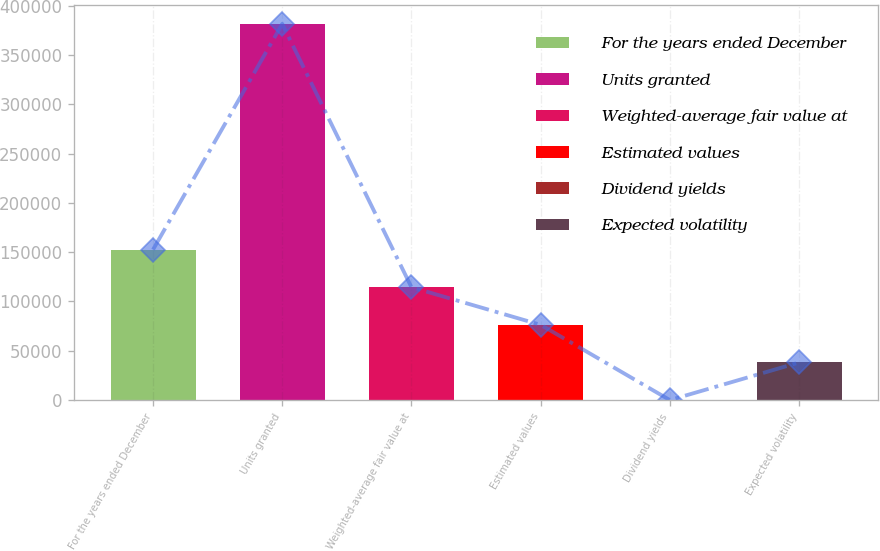Convert chart to OTSL. <chart><loc_0><loc_0><loc_500><loc_500><bar_chart><fcel>For the years ended December<fcel>Units granted<fcel>Weighted-average fair value at<fcel>Estimated values<fcel>Dividend yields<fcel>Expected volatility<nl><fcel>152564<fcel>381407<fcel>114424<fcel>76283<fcel>2<fcel>38142.5<nl></chart> 